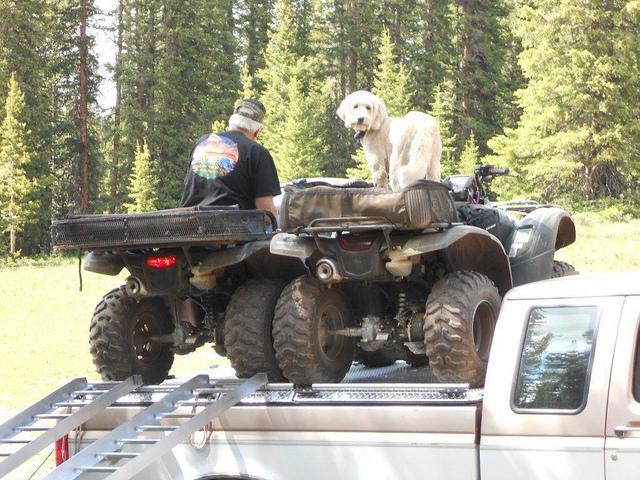Is the dog on a 4 wheeler?
Give a very brief answer. Yes. What vehicles are shown?
Write a very short answer. Atv. How will the 4 wheelers get down from the truck?
Keep it brief. Ramp. 